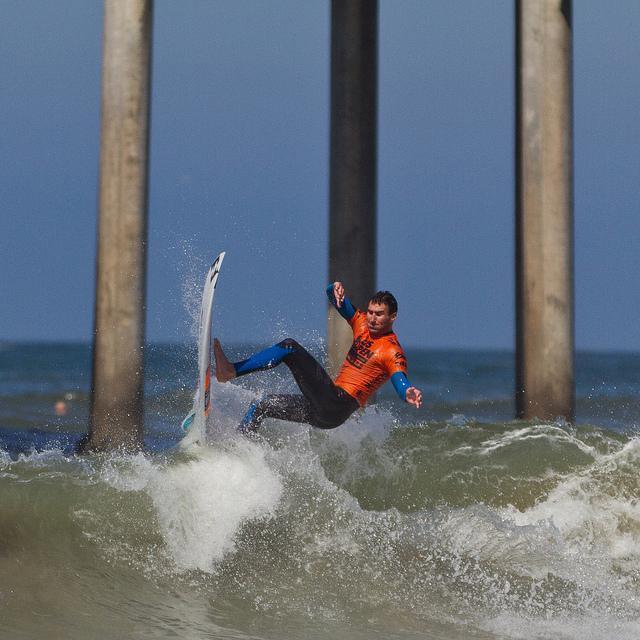How many surfboards are there?
Give a very brief answer. 1. How many black cats are in the image?
Give a very brief answer. 0. 